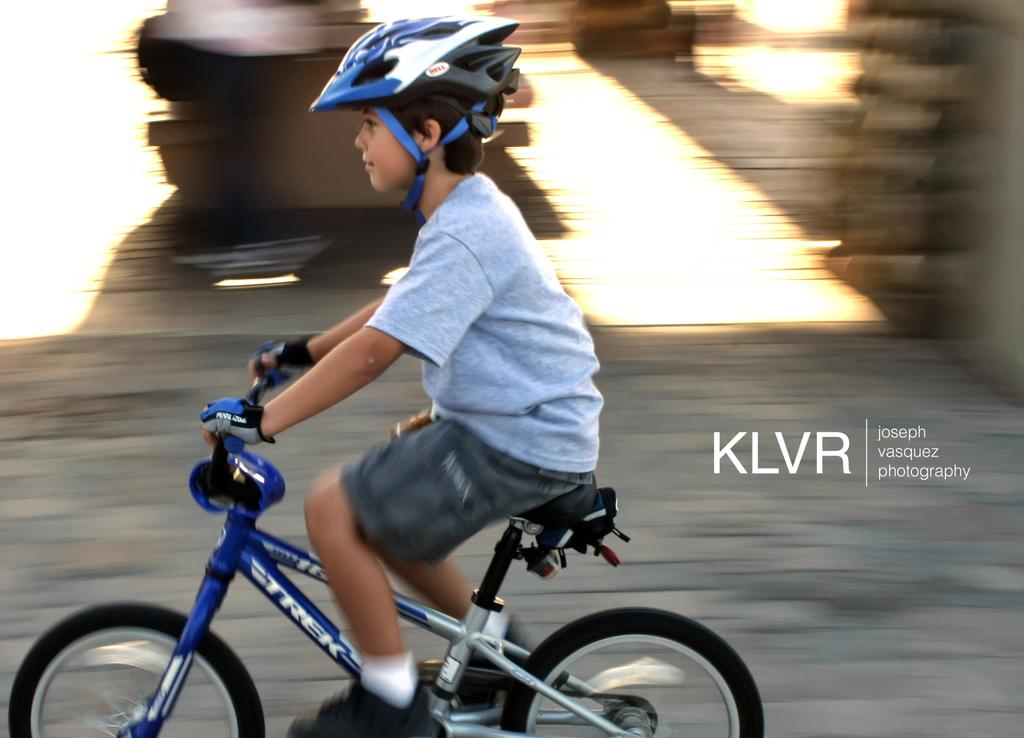What is the main subject of the image? The main subject of the image is a child. What is the child doing in the image? The child is riding a bicycle in the image. What safety precaution is the child taking while riding the bicycle? The child is wearing a helmet in the image. What color is the child's heart in the image? There is no visible heart in the image, so we cannot determine its color. 